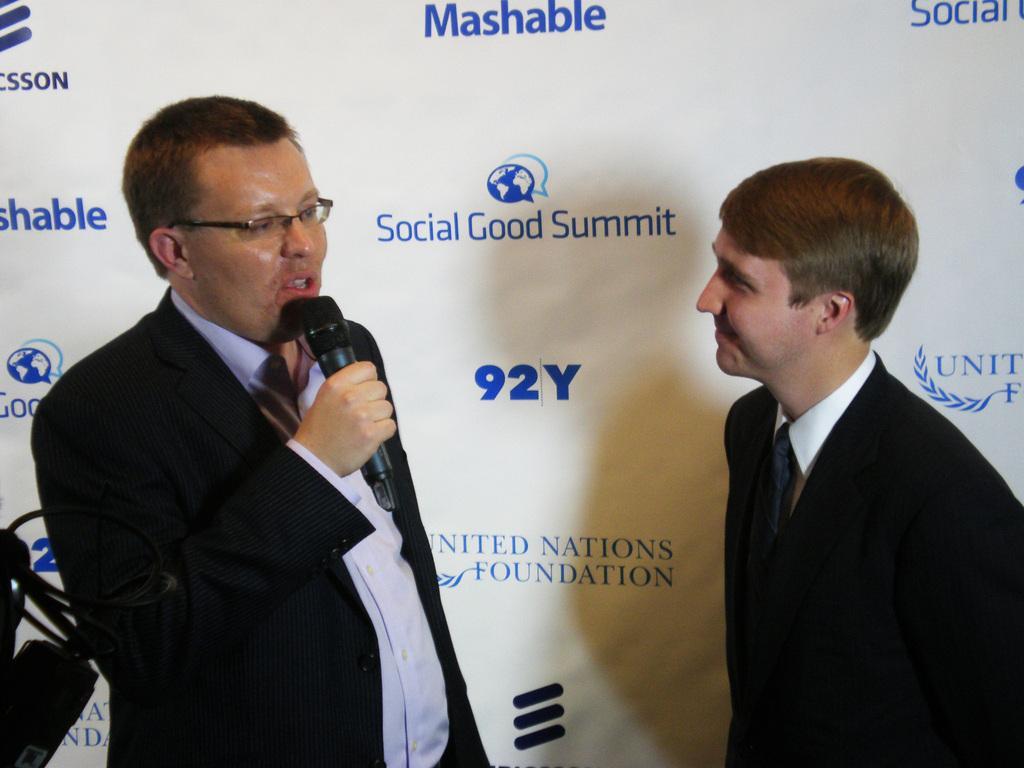In one or two sentences, can you explain what this image depicts? In this picture we can see there are two people standing on the path and a man is holding a microphone. Behind the people there is a banner. 